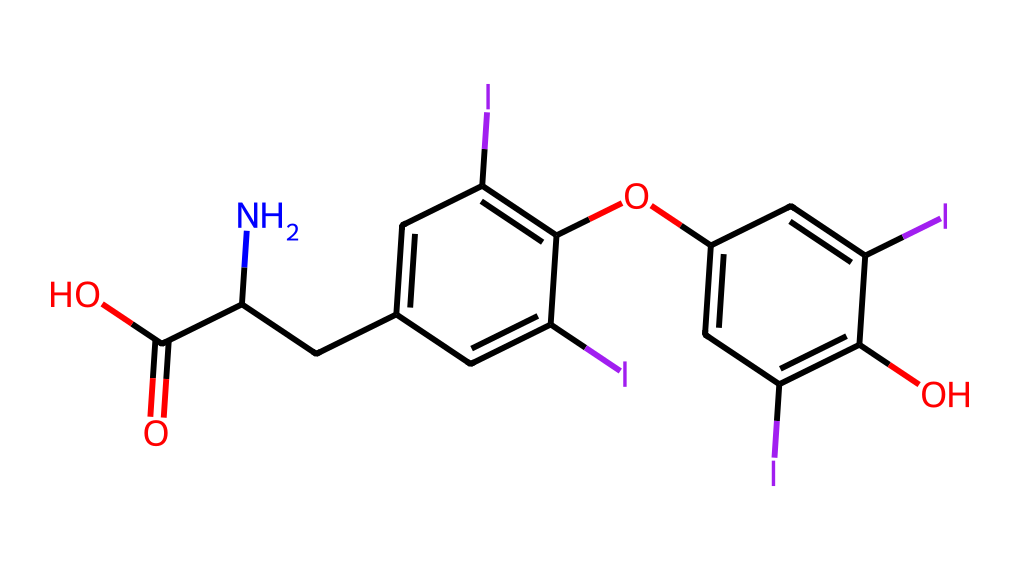What is the name of the hormone represented by this structure? The SMILES representation corresponds to thyroxine, a thyroid hormone involved in regulating metabolism.
Answer: thyroxine How many iodine atoms are present in this structure? Upon examining the structure, there are four iodine atoms attached to the aromatic rings.
Answer: four What is the functional group indicated by the "C(=O)O" in the SMILES? The "C(=O)O" represents a carboxylic acid functional group, characterized by a carbonyl group (C=O) adjacent to a hydroxyl group (–OH).
Answer: carboxylic acid What type of chemical bond primarily connects the carbon atoms in the structure? The primary bonds connecting the carbon atoms in this structure are covalent bonds, which involve the sharing of electron pairs between atoms.
Answer: covalent What is the characteristic feature of thyroxine that relates to its role in metabolism? The presence of multiple iodine atoms is characteristic, as iodine is crucial for the hormone's biological activity and its effectiveness in regulating metabolic processes.
Answer: iodine atoms Does this molecule contain any heteroatoms? Yes, the molecule contains heteroatoms, which are atoms other than carbon and hydrogen; in this case, nitrogen and oxygen are present.
Answer: nitrogen, oxygen 